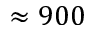<formula> <loc_0><loc_0><loc_500><loc_500>\approx 9 0 0</formula> 